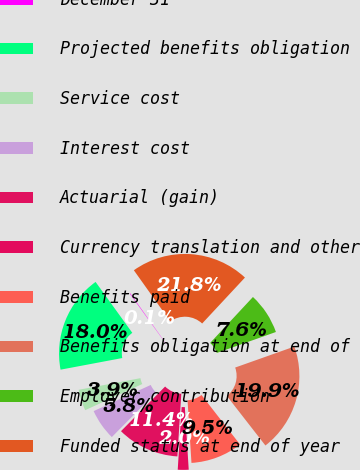<chart> <loc_0><loc_0><loc_500><loc_500><pie_chart><fcel>December 31<fcel>Projected benefits obligation<fcel>Service cost<fcel>Interest cost<fcel>Actuarial (gain)<fcel>Currency translation and other<fcel>Benefits paid<fcel>Benefits obligation at end of<fcel>Employer contribution<fcel>Funded status at end of year<nl><fcel>0.1%<fcel>18.02%<fcel>3.87%<fcel>5.76%<fcel>11.41%<fcel>1.99%<fcel>9.53%<fcel>19.9%<fcel>7.64%<fcel>21.78%<nl></chart> 